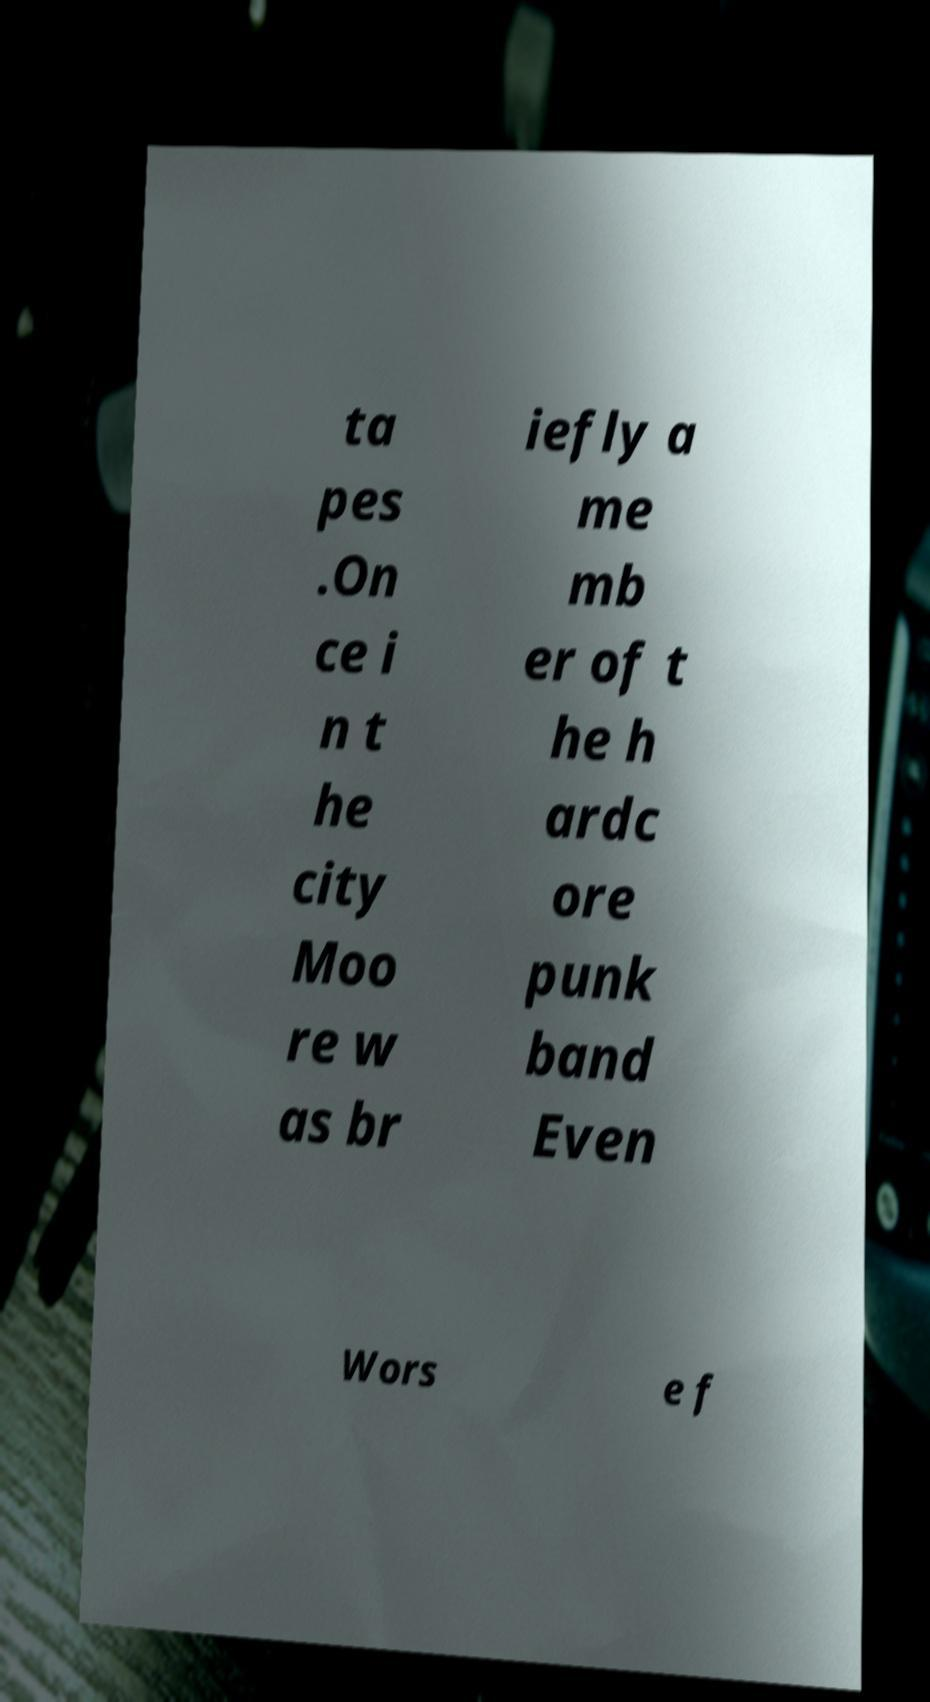For documentation purposes, I need the text within this image transcribed. Could you provide that? ta pes .On ce i n t he city Moo re w as br iefly a me mb er of t he h ardc ore punk band Even Wors e f 